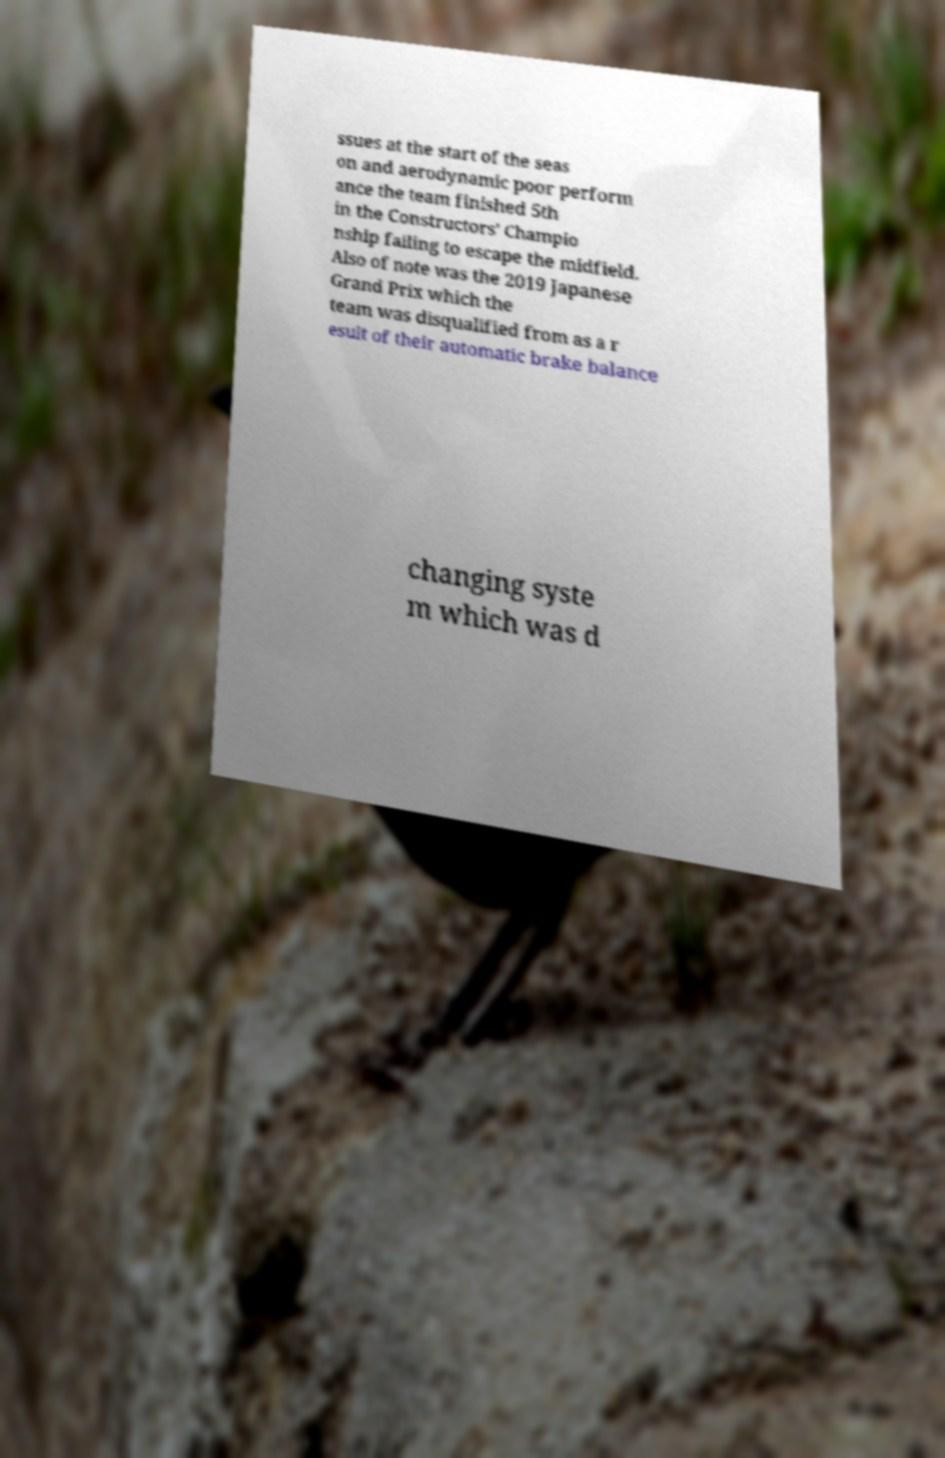Please read and relay the text visible in this image. What does it say? ssues at the start of the seas on and aerodynamic poor perform ance the team finished 5th in the Constructors' Champio nship failing to escape the midfield. Also of note was the 2019 Japanese Grand Prix which the team was disqualified from as a r esult of their automatic brake balance changing syste m which was d 